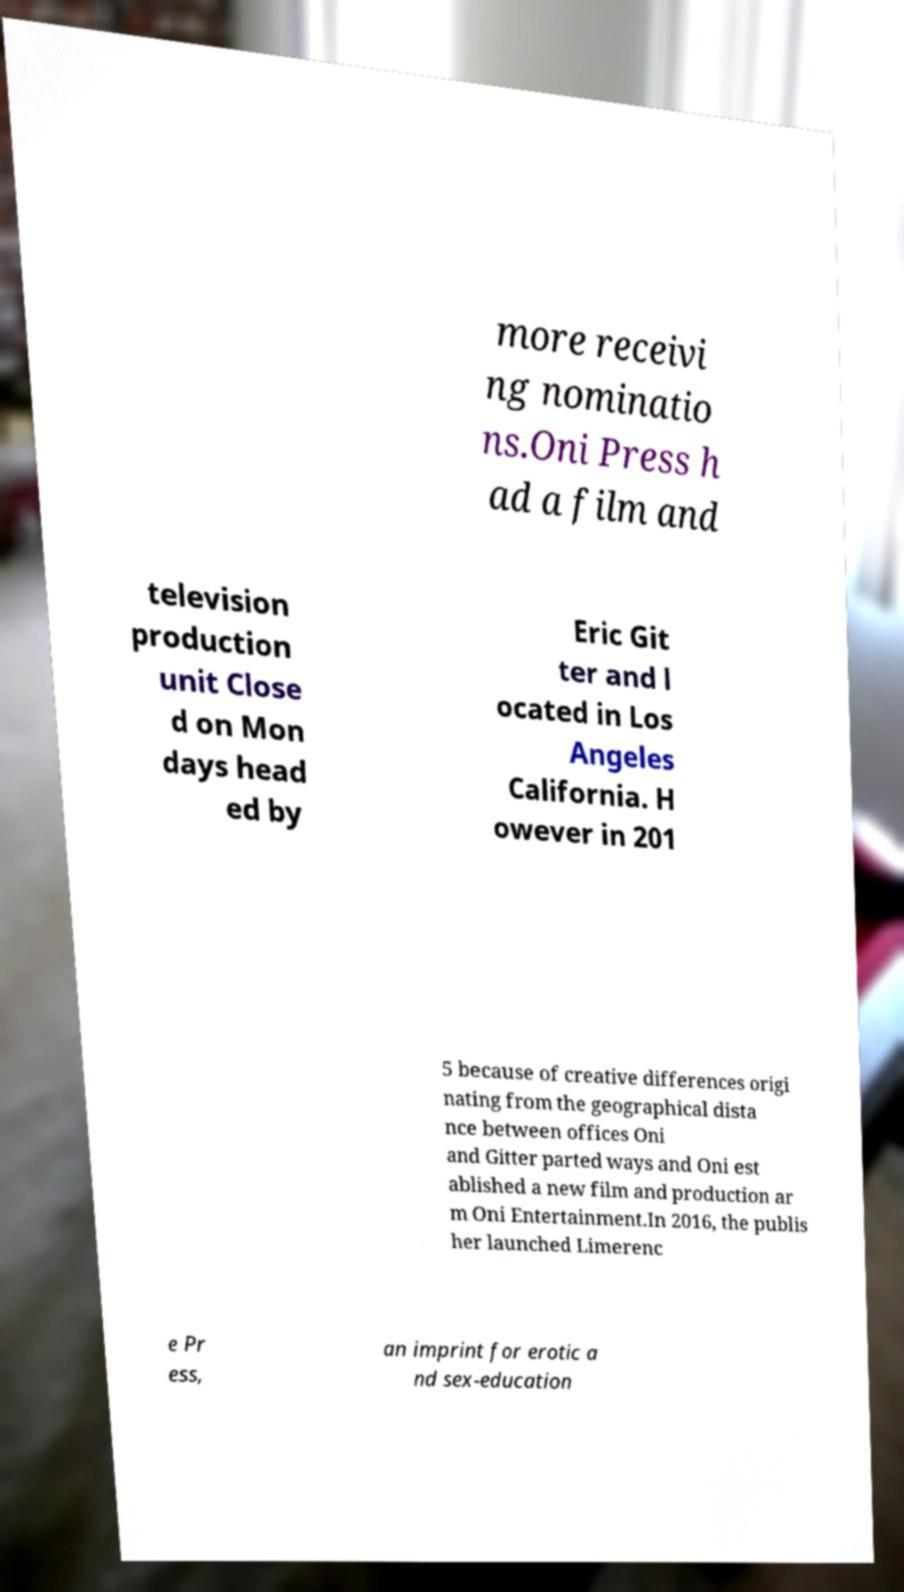Could you extract and type out the text from this image? more receivi ng nominatio ns.Oni Press h ad a film and television production unit Close d on Mon days head ed by Eric Git ter and l ocated in Los Angeles California. H owever in 201 5 because of creative differences origi nating from the geographical dista nce between offices Oni and Gitter parted ways and Oni est ablished a new film and production ar m Oni Entertainment.In 2016, the publis her launched Limerenc e Pr ess, an imprint for erotic a nd sex-education 